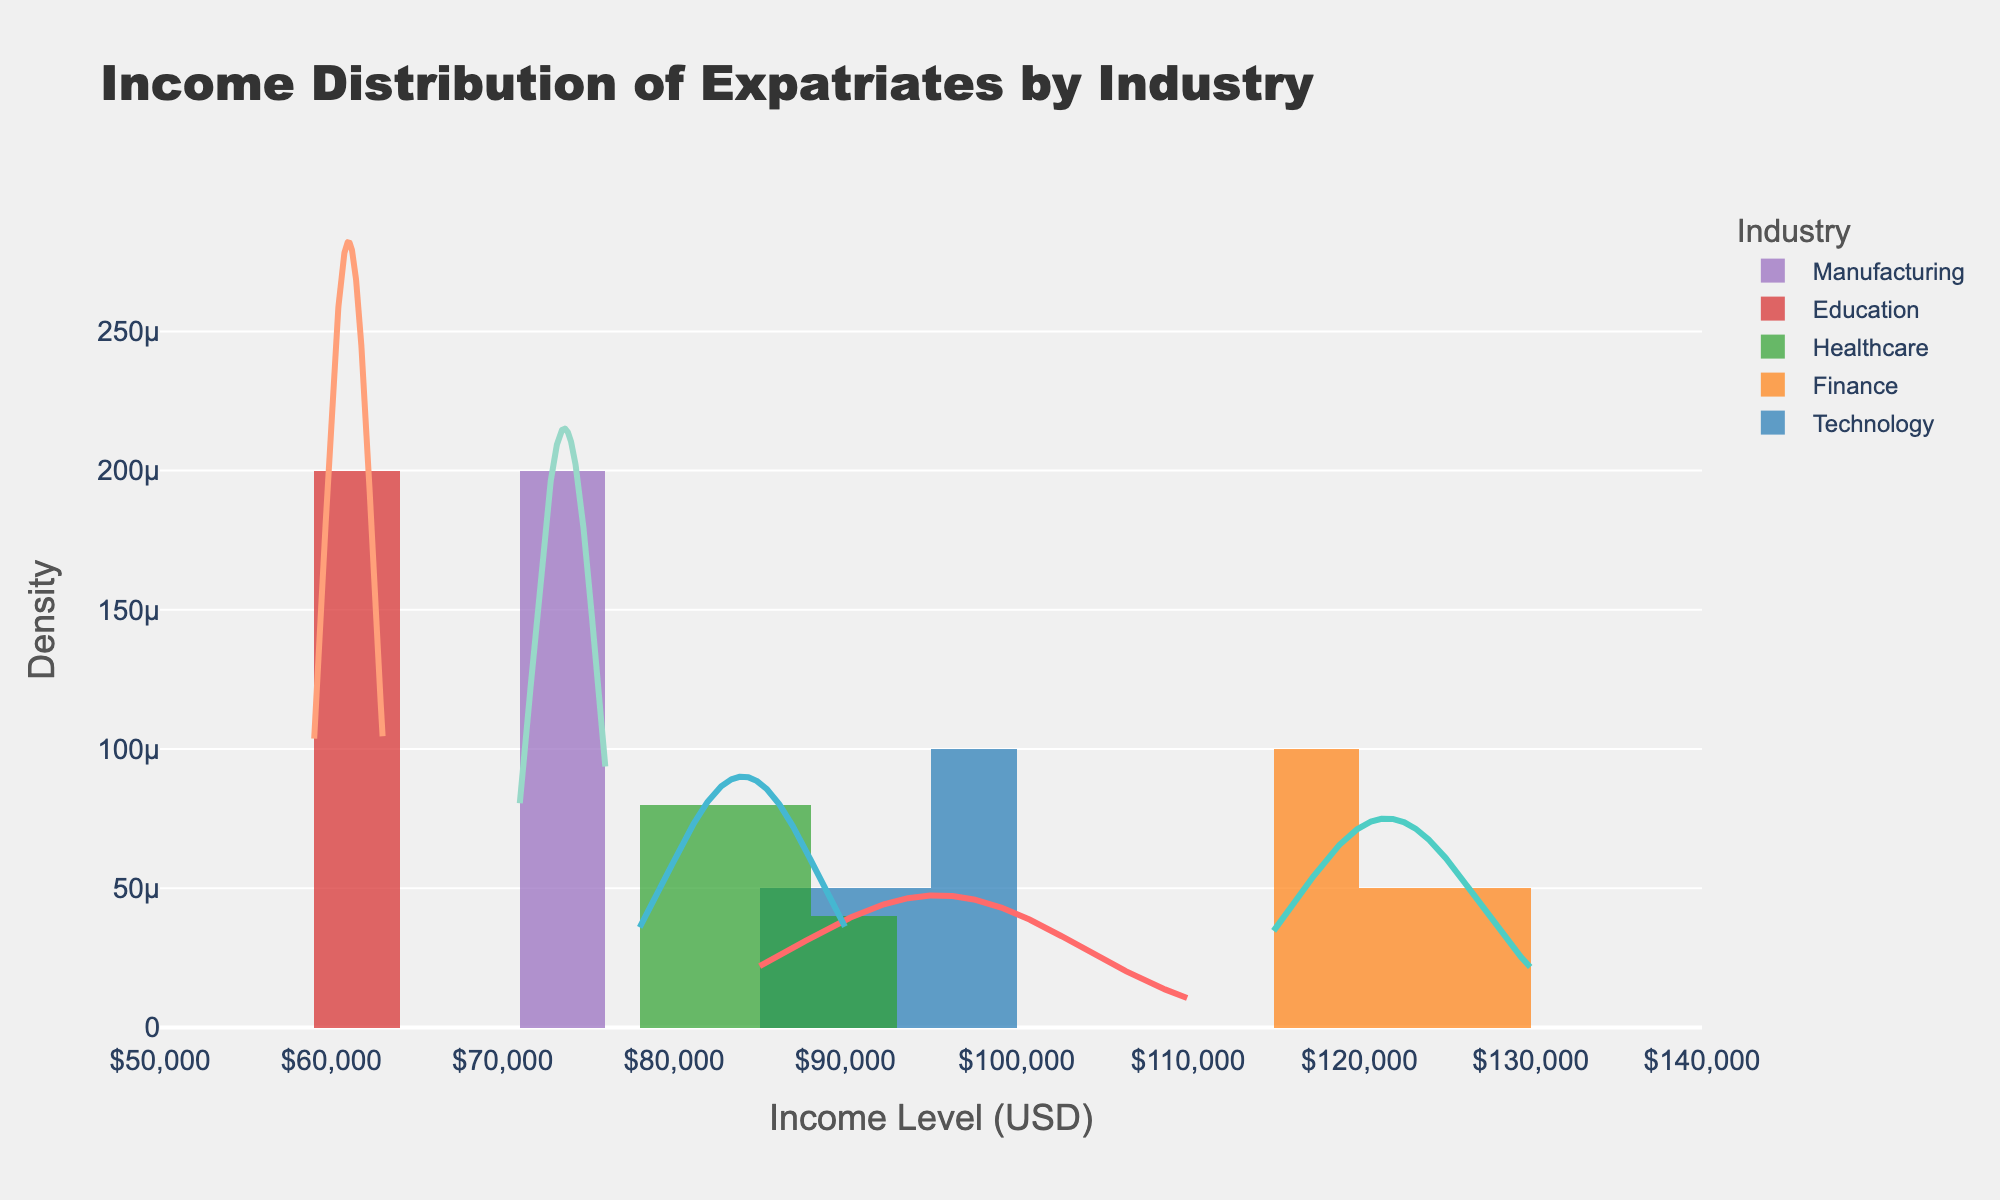What is the title of the plot? The title of the plot is located at the top-center of the figure and serves as a summary of what the figure represents. By examining the title, one can understand the main topic of the visualization.
Answer: Income Distribution of Expatriates by Industry Which industry appears to have the highest income distribution peak? By looking at the density peaks of each industry's distribution curve, the industry with the highest peak can be identified.
Answer: Finance What is the approximate income range for expats in the Education industry? By observing the width of the Education industry's curve on the x-axis, the range of incomes for this industry can be determined.
Answer: $59,000 to $63,000 Which industry has the widest distribution of income levels? The industry with the widest distribution has the most extended curve on the x-axis, indicating a more varied range of income levels.
Answer: Finance How does the peak income distribution for Manufacturing compare to Healthcare? By comparing the height and position of the peaks for the curves of the Manufacturing and Healthcare industries, their income distributions can be compared.
Answer: The peak for Manufacturing is lower and shifted to a lower income level than Healthcare What is the bin size used for the histogram in the distplot? The bin size is typically mentioned in the figure's configuration, which indicates the width of each bar in the histogram part of the distplot.
Answer: $5,000 Which two industries have the closest peak income distribution values? By comparing the positions and heights of the peaks of all industries' curves, the two industries with the most similar peaks can be identified.
Answer: Technology and Healthcare Is there any industry with a bimodal distribution? A bimodal distribution has two distinct peaks. By examining the shapes of all the curves, an industry with two peaks can be identified.
Answer: No Are there any outliers visible in the distribution curves? Outliers would appear as unusually high spikes or isolated points in the distribution curves.
Answer: No Which industry shows the lowest density in its distribution curve? By comparing the heights of the distribution curves, the industry with the lowest peak can be identified.
Answer: Education 